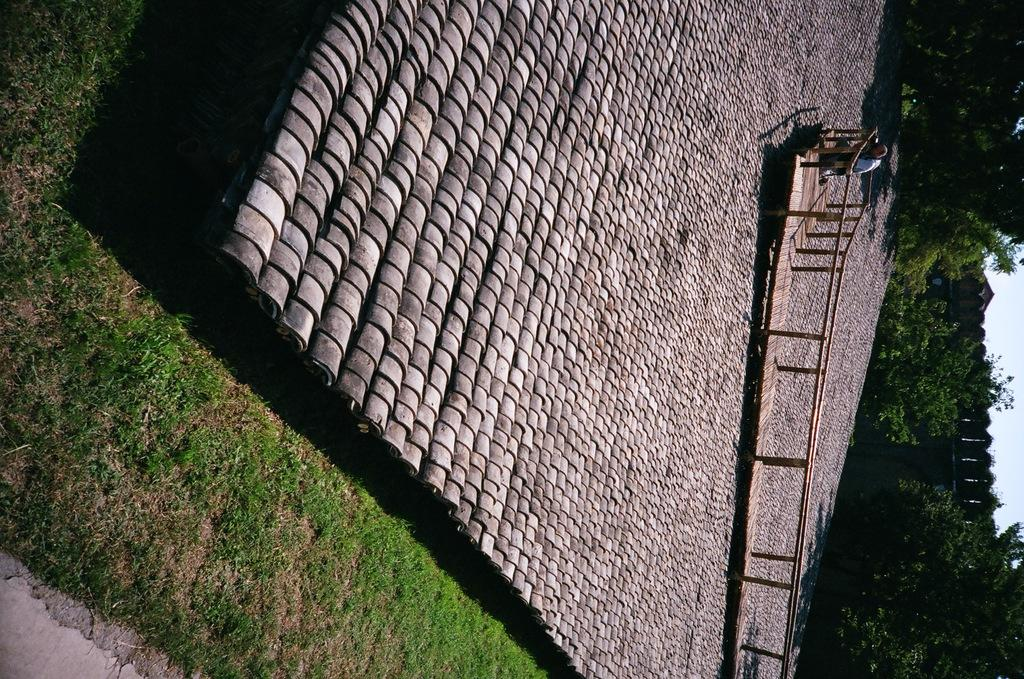What type of material is used for the rods in the image? The rods in the image are made of metal. Can you describe the person in the image? There is a person in the image, but no specific details about their appearance or actions are provided. What other objects can be seen in the image besides the metal rods? There are cement stones in the image. What type of natural environment is visible in the image? The image shows grass, and there are trees and buildings in the background. What is visible in the sky in the image? The sky is visible in the background of the image. Can you suggest a possible location where the image might have been taken? The image may have been taken in a park, based on the presence of grass, trees, and buildings. What type of advertisement can be seen on the window in the image? There is no window or advertisement present in the image. How does the person in the image start their day? The image does not provide any information about the person's actions or daily routine, so it cannot be determined how they start their day. 